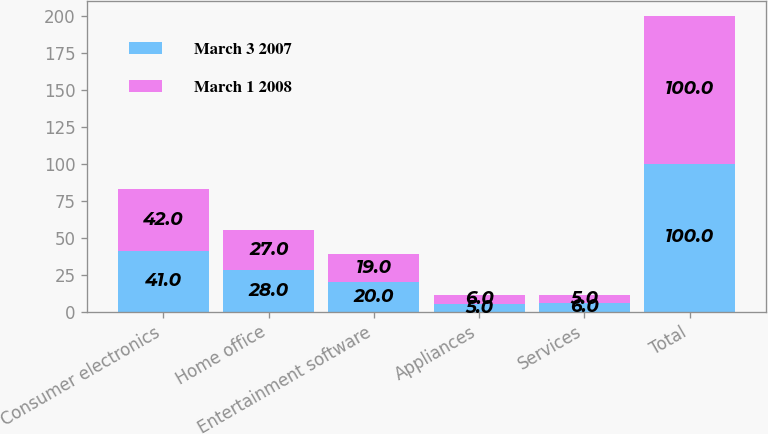Convert chart to OTSL. <chart><loc_0><loc_0><loc_500><loc_500><stacked_bar_chart><ecel><fcel>Consumer electronics<fcel>Home office<fcel>Entertainment software<fcel>Appliances<fcel>Services<fcel>Total<nl><fcel>March 3 2007<fcel>41<fcel>28<fcel>20<fcel>5<fcel>6<fcel>100<nl><fcel>March 1 2008<fcel>42<fcel>27<fcel>19<fcel>6<fcel>5<fcel>100<nl></chart> 